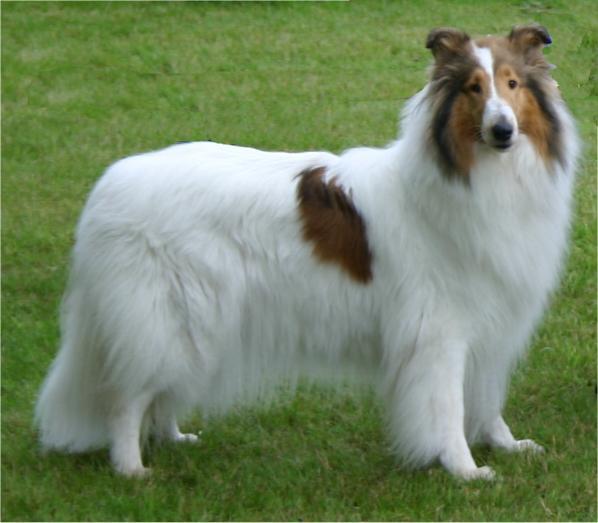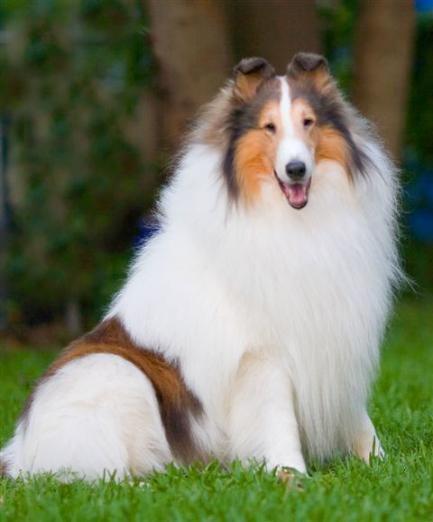The first image is the image on the left, the second image is the image on the right. Given the left and right images, does the statement "In 1 of the images, 1 dog has an open mouth." hold true? Answer yes or no. Yes. 